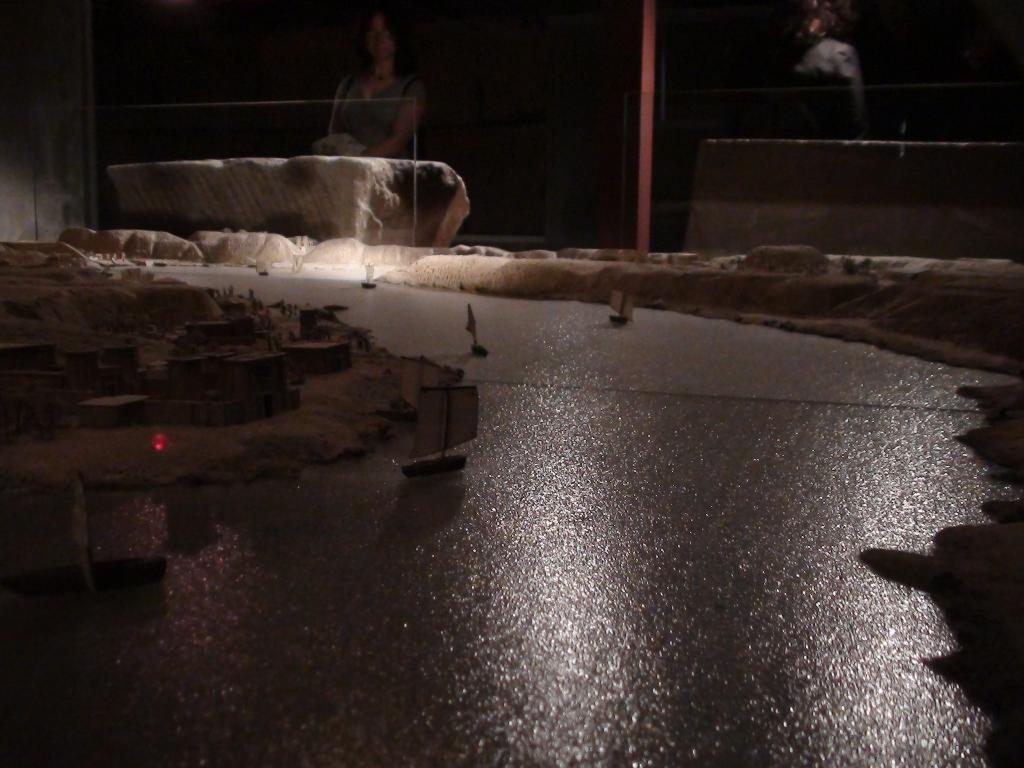How would you summarize this image in a sentence or two? In this image we can see some boats on the water. We can also see some houses on the land. On the backside we can see a person standing. 